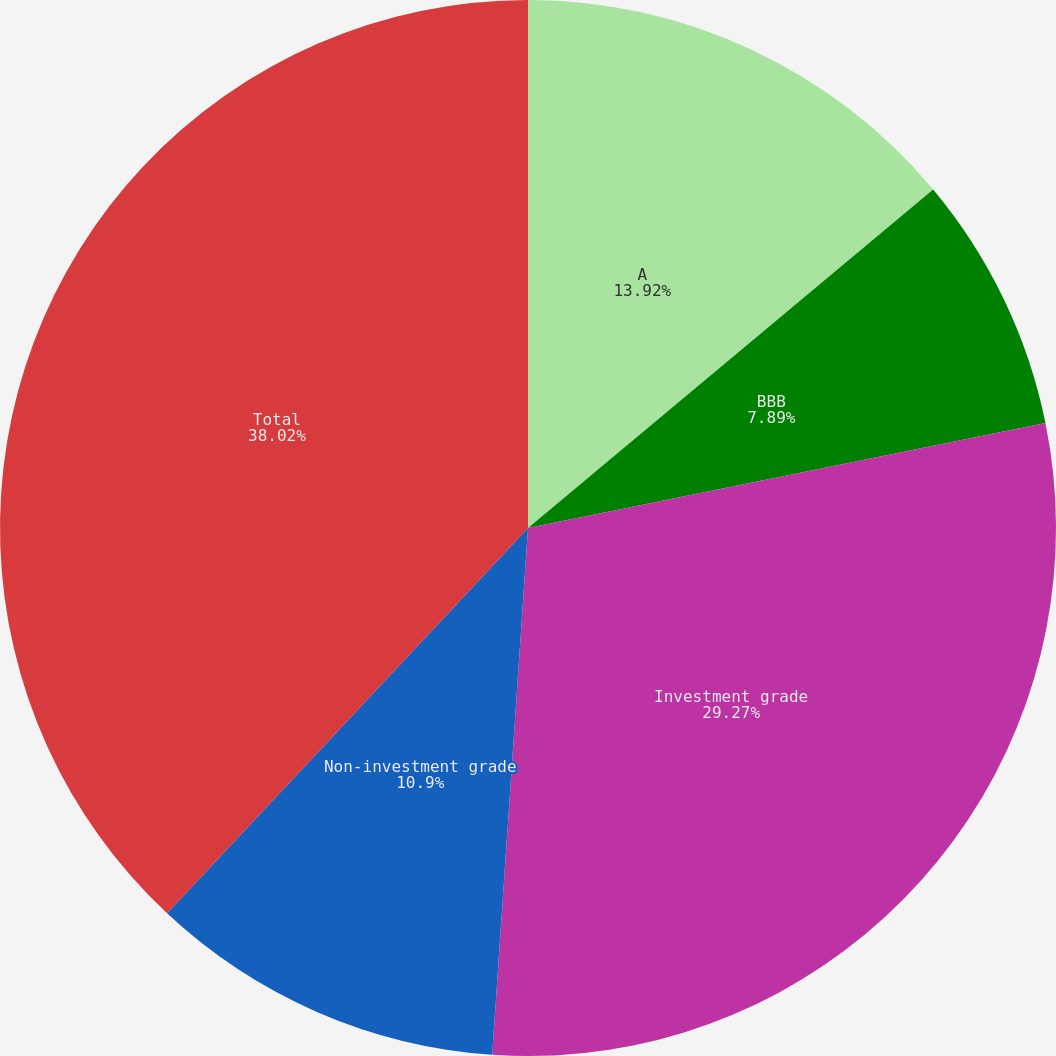Convert chart. <chart><loc_0><loc_0><loc_500><loc_500><pie_chart><fcel>A<fcel>BBB<fcel>Investment grade<fcel>Non-investment grade<fcel>Total<nl><fcel>13.92%<fcel>7.89%<fcel>29.27%<fcel>10.9%<fcel>38.02%<nl></chart> 